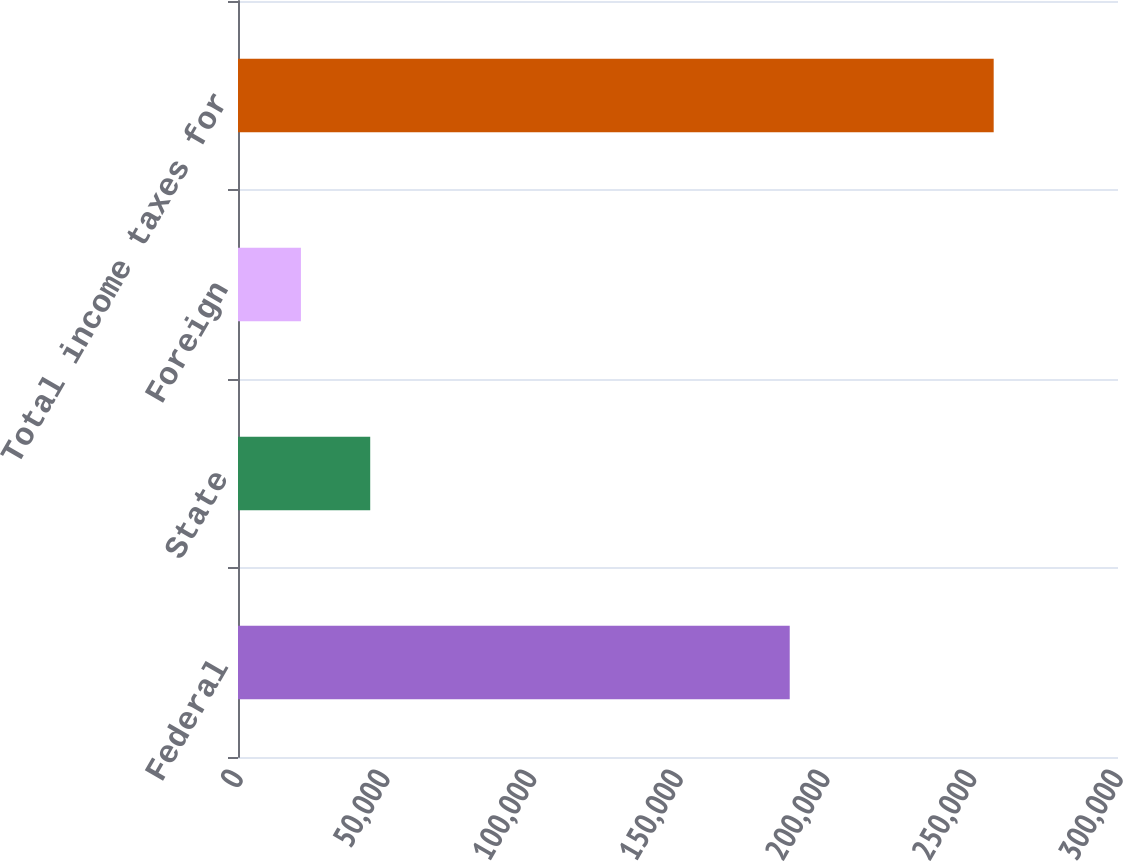<chart> <loc_0><loc_0><loc_500><loc_500><bar_chart><fcel>Federal<fcel>State<fcel>Foreign<fcel>Total income taxes for<nl><fcel>188086<fcel>45072.4<fcel>21456<fcel>257620<nl></chart> 